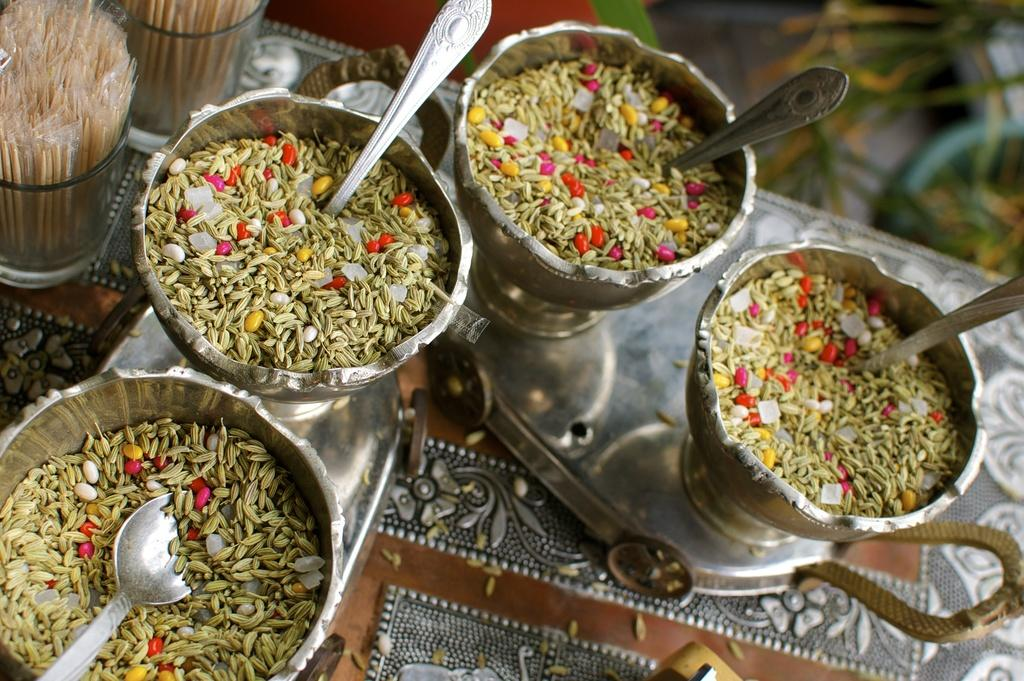What is in the bowls that are visible in the image? There are bowls filled with mouth fresheners in the image. What utensils are present in the image? There are spoons visible in the image. How are the bowls and spoons arranged in the image? The bowls and spoons are placed on a tray in the image. Where can toothpicks be found in the image? Toothpicks are in two glasses in the left side top corner of the image. How does the image increase in size when viewed? The image does not increase in size when viewed; its size remains constant. 